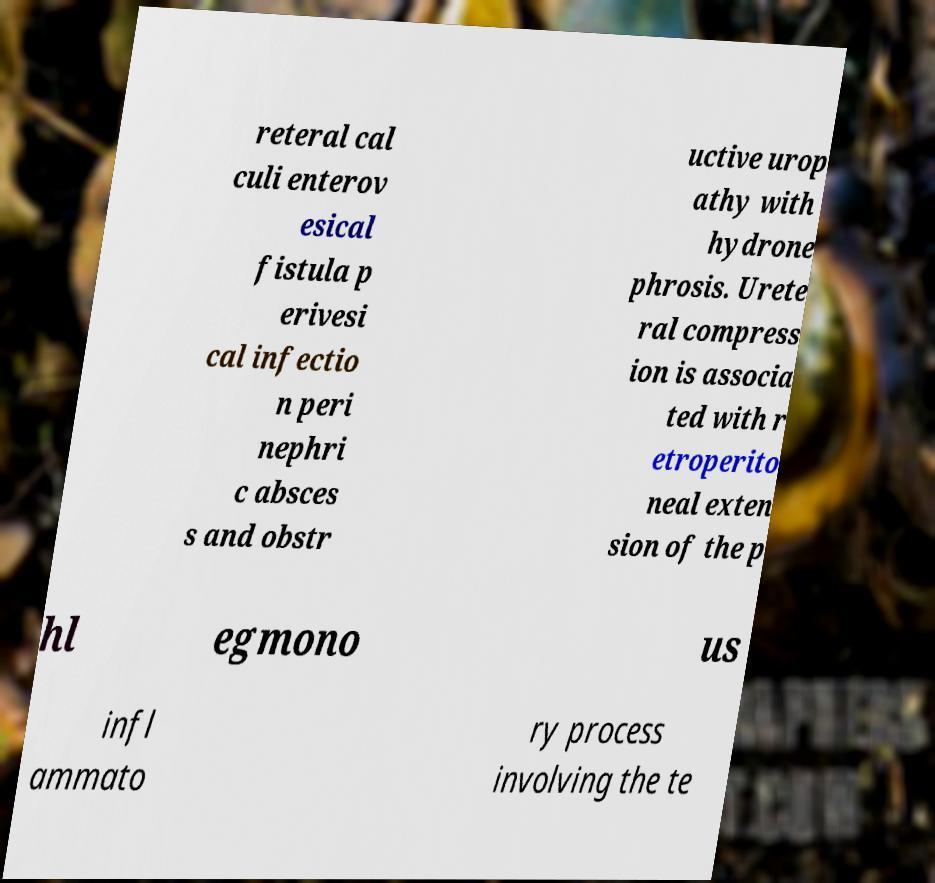Could you extract and type out the text from this image? reteral cal culi enterov esical fistula p erivesi cal infectio n peri nephri c absces s and obstr uctive urop athy with hydrone phrosis. Urete ral compress ion is associa ted with r etroperito neal exten sion of the p hl egmono us infl ammato ry process involving the te 